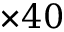<formula> <loc_0><loc_0><loc_500><loc_500>\times 4 0</formula> 